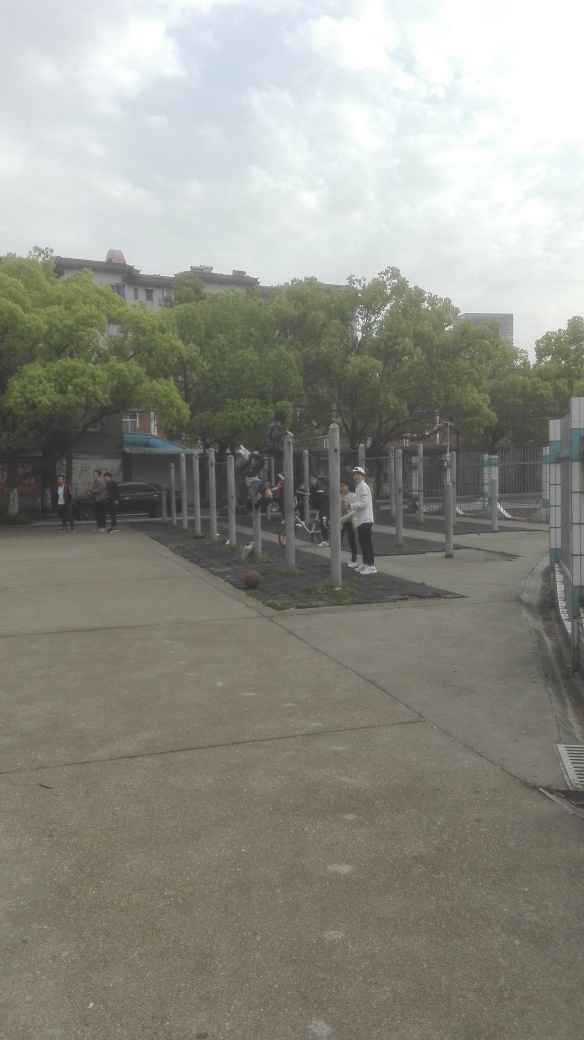Is the area well-equipped for fitness activities? Yes, the area in the image is equipped with a variety of vertical bars of different heights suitable for body-weight exercises like pull-ups and dips. There's also ample open space for other types of exercises or stretches, making it a versatile spot for outdoor workouts. Do you think the setup promotes a sense of community? Definitely, the open and accessible design of the fitness area encourages people to exercise in a shared space, which can foster a sense of community. It provides an environment for individuals to be active together, possibly motivating one another or sharing tips. 